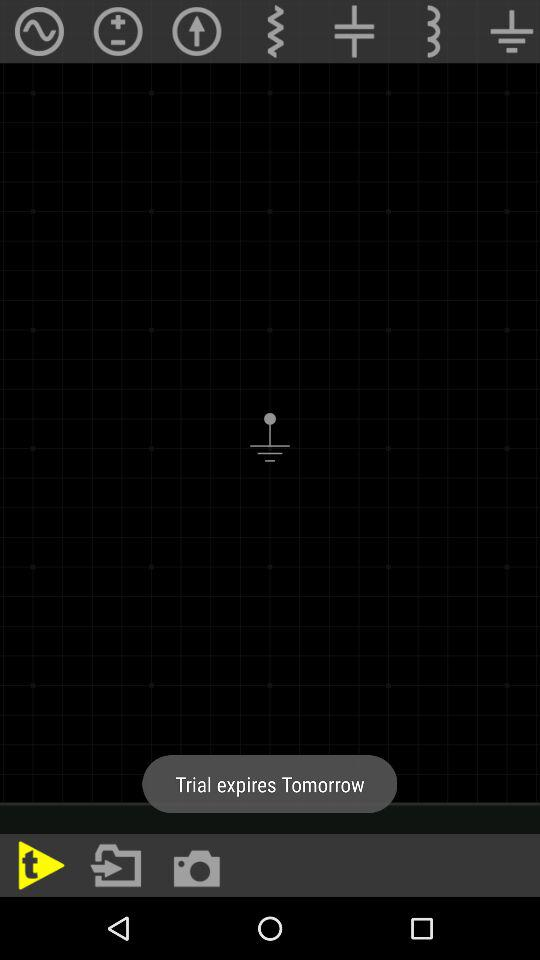When will the trial expire? The trail will expire tomorrow. 